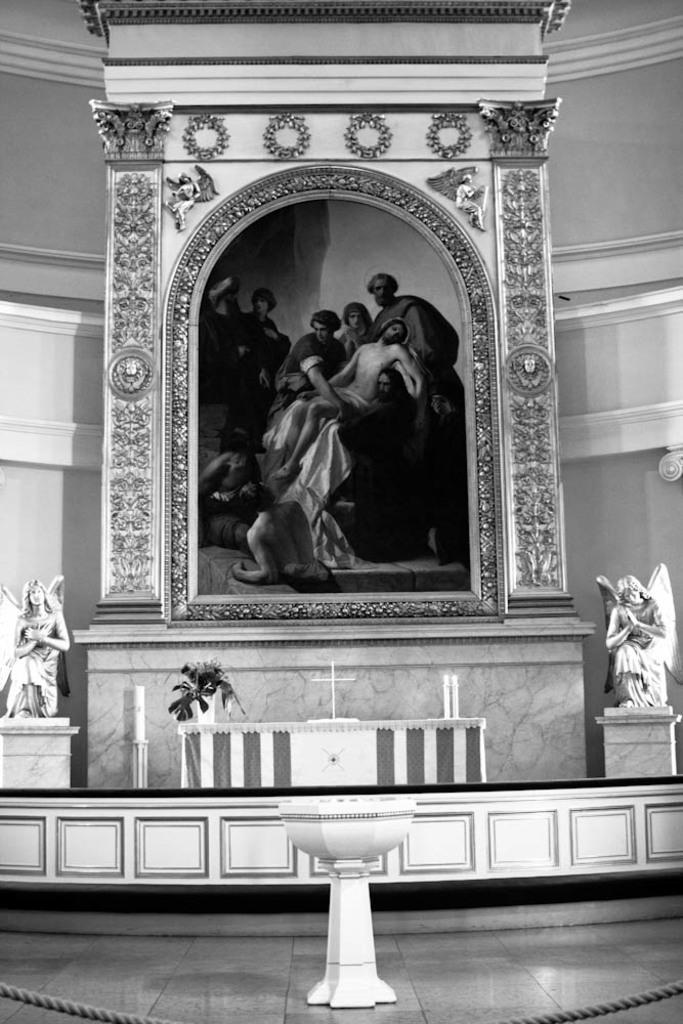How would you summarize this image in a sentence or two? In this picture there is an image of few persons and there is a designed wall around it and there is a statue on either sides of it and there are few objects in front of the image. 